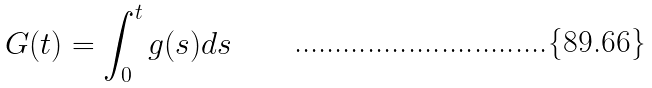Convert formula to latex. <formula><loc_0><loc_0><loc_500><loc_500>G ( t ) = \int _ { 0 } ^ { t } g ( s ) d s</formula> 